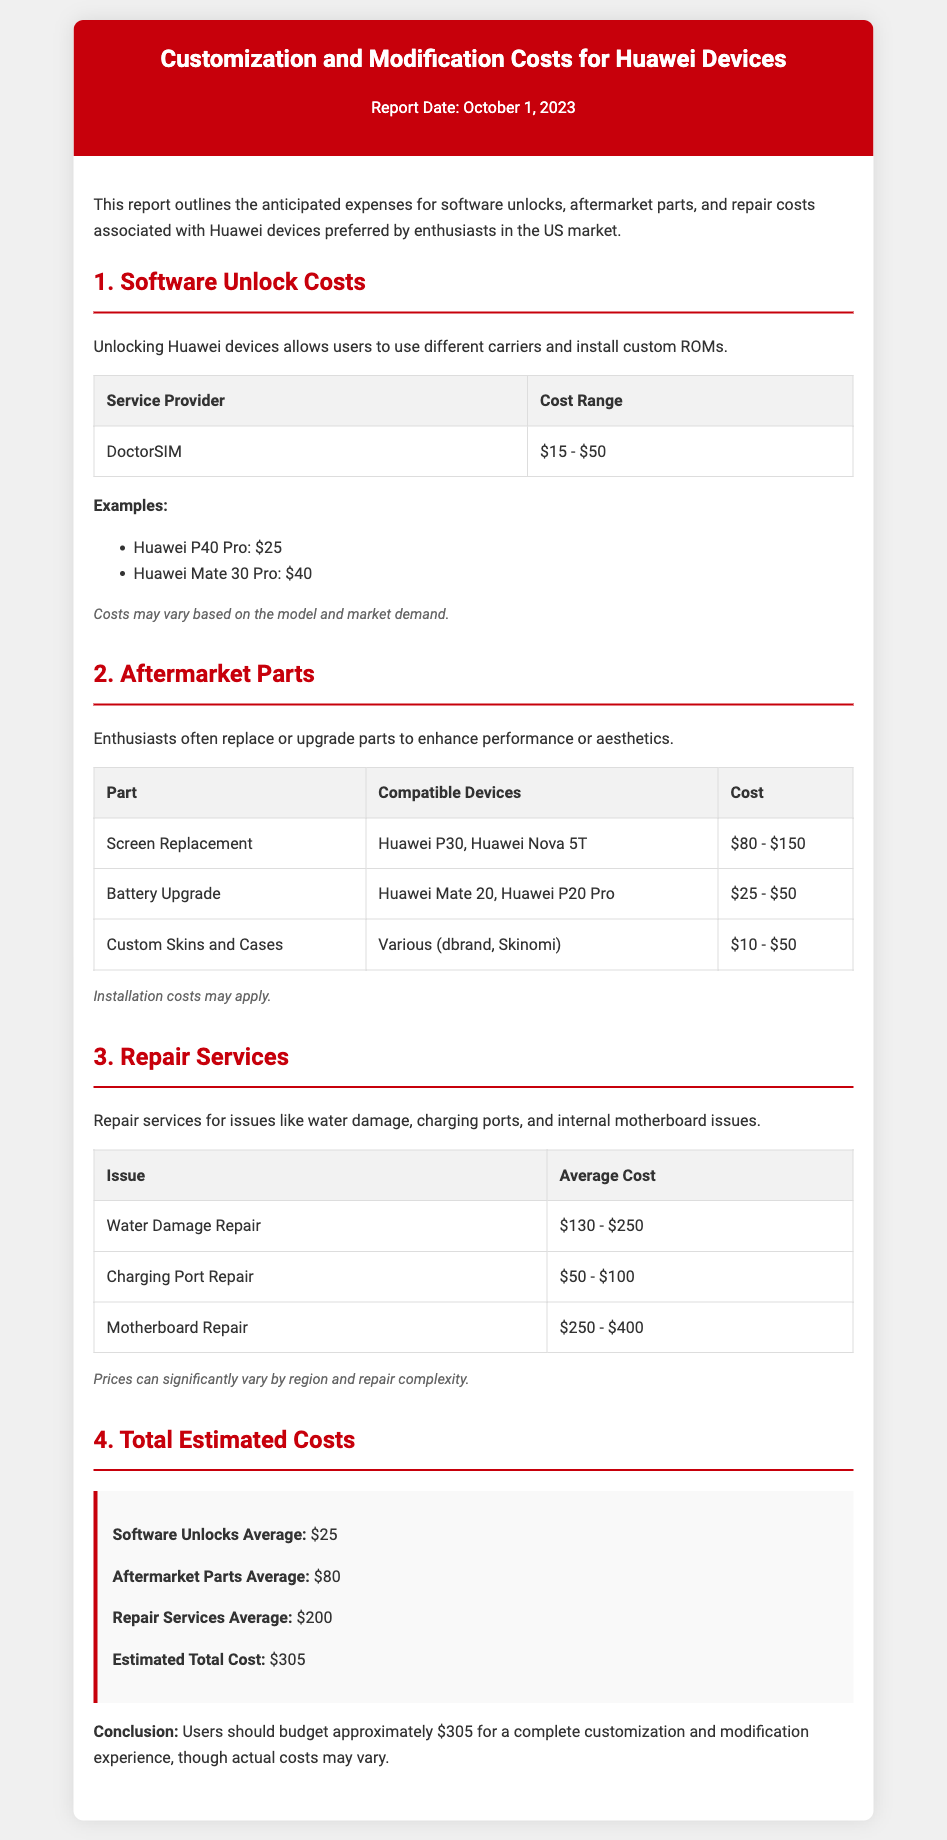What is the average cost range for software unlocks? The average cost range for software unlocks is outlined in the section about Software Unlock Costs, ranging from $15 to $50.
Answer: $15 - $50 What is the estimated total cost for a complete customization experience? The Estimated Total Cost is summarized in the Total Estimated Costs section, which specifically mentions it as approximately $305.
Answer: $305 What is the cost of water damage repair? The document includes details about the average cost of water damage repair found in the Repair Services section, which ranges from $130 to $250.
Answer: $130 - $250 What aftermarket part costs between $10 and $50? The table in the Aftermarket Parts section lists Custom Skins and Cases, which fall into this cost range.
Answer: Custom Skins and Cases What is the average cost for an aftermarket battery upgrade? The average cost for an aftermarket battery upgrade, as mentioned in the Aftermarket Parts section, ranges from $25 to $50.
Answer: $25 - $50 Which service provider is mentioned for software unlocking? The Software Unlock Costs section identifies DoctorSIM as the service provider for unlocking.
Answer: DoctorSIM How much does the repair of a charging port typically cost? The average cost for charging port repair is detailed in the Repair Services section, ranging from $50 to $100.
Answer: $50 - $100 What are the average costs for repair services? The Total Estimated Costs section highlights the average costs for repair services, which is listed as $200.
Answer: $200 Which Huawei device has a listed unlock cost of $40? The examples section specifies the Huawei Mate 30 Pro with an unlock cost of $40.
Answer: Huawei Mate 30 Pro 